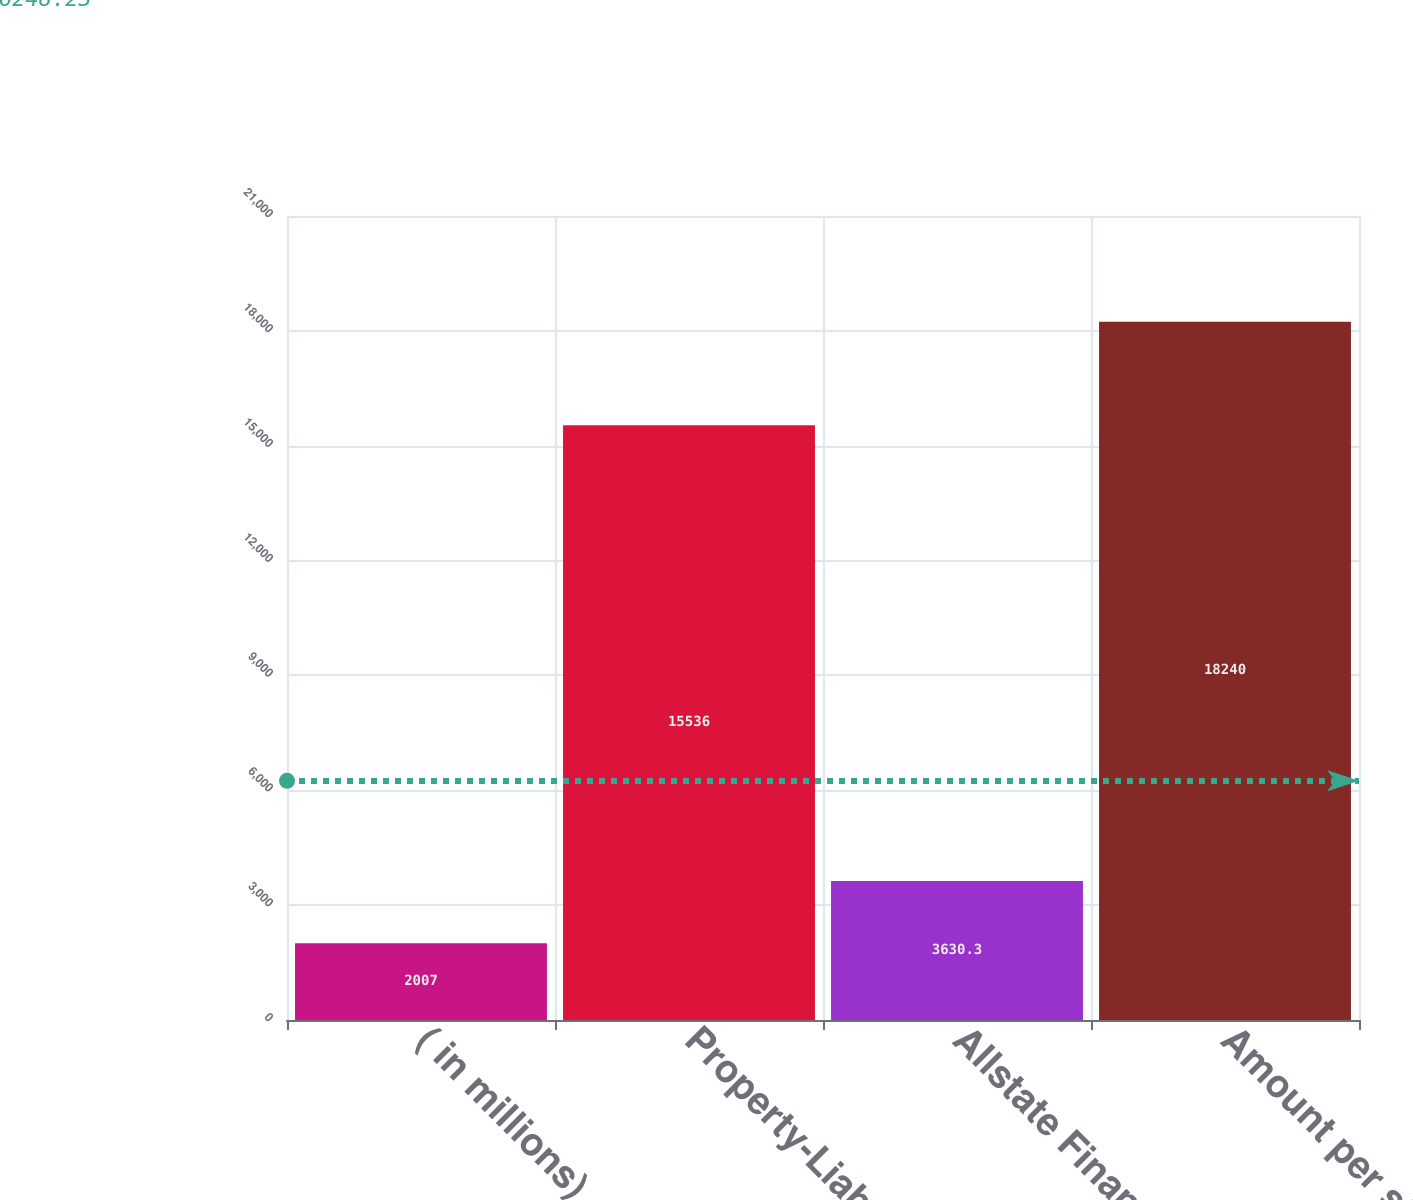<chart> <loc_0><loc_0><loc_500><loc_500><bar_chart><fcel>( in millions)<fcel>Property-Liability<fcel>Allstate Financial<fcel>Amount per statutory<nl><fcel>2007<fcel>15536<fcel>3630.3<fcel>18240<nl></chart> 